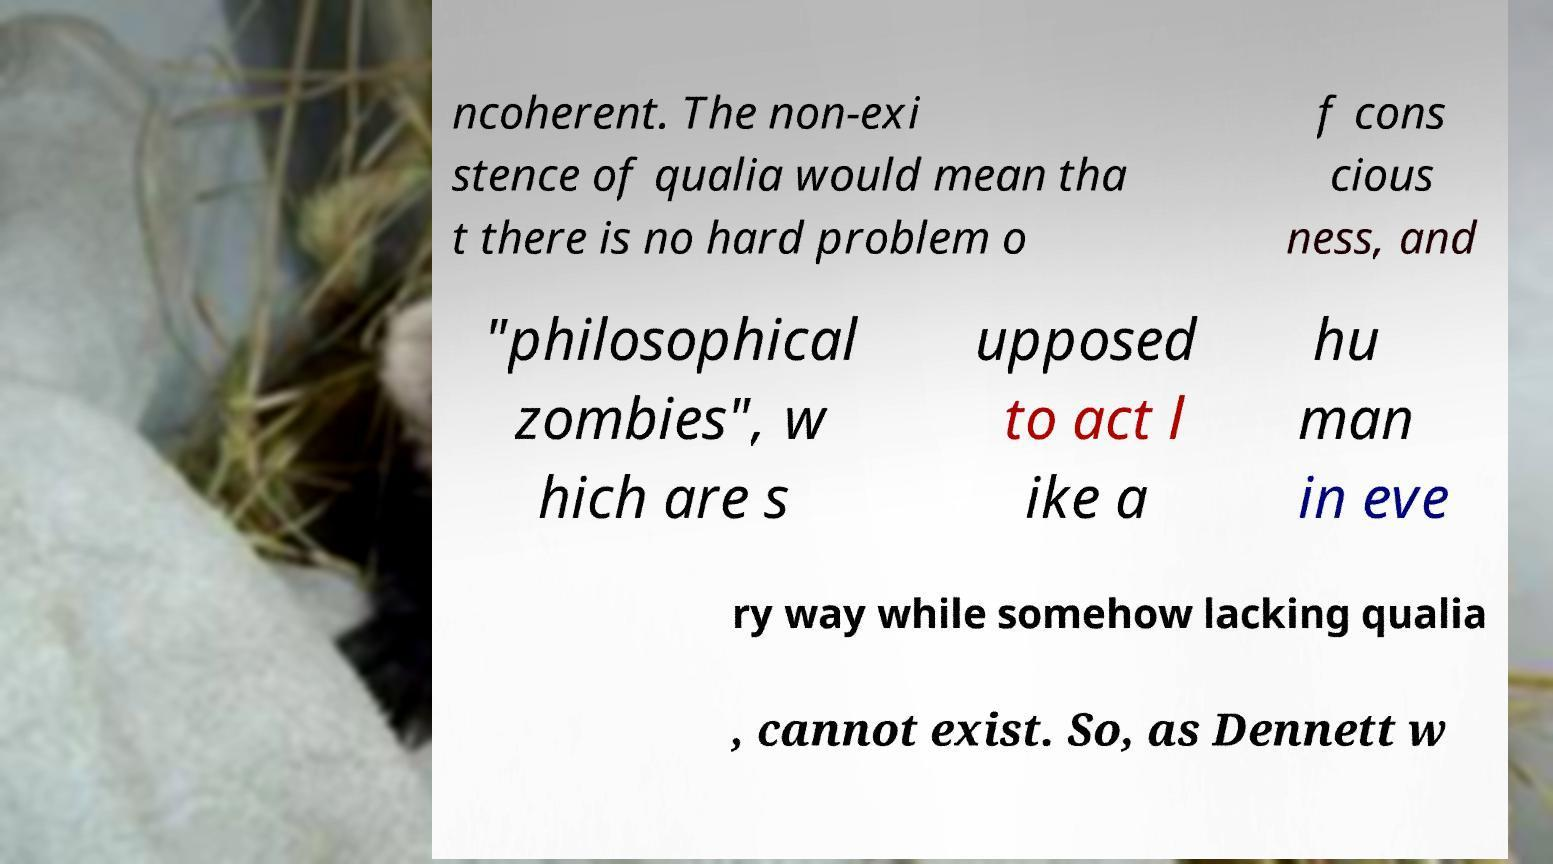What messages or text are displayed in this image? I need them in a readable, typed format. ncoherent. The non-exi stence of qualia would mean tha t there is no hard problem o f cons cious ness, and "philosophical zombies", w hich are s upposed to act l ike a hu man in eve ry way while somehow lacking qualia , cannot exist. So, as Dennett w 